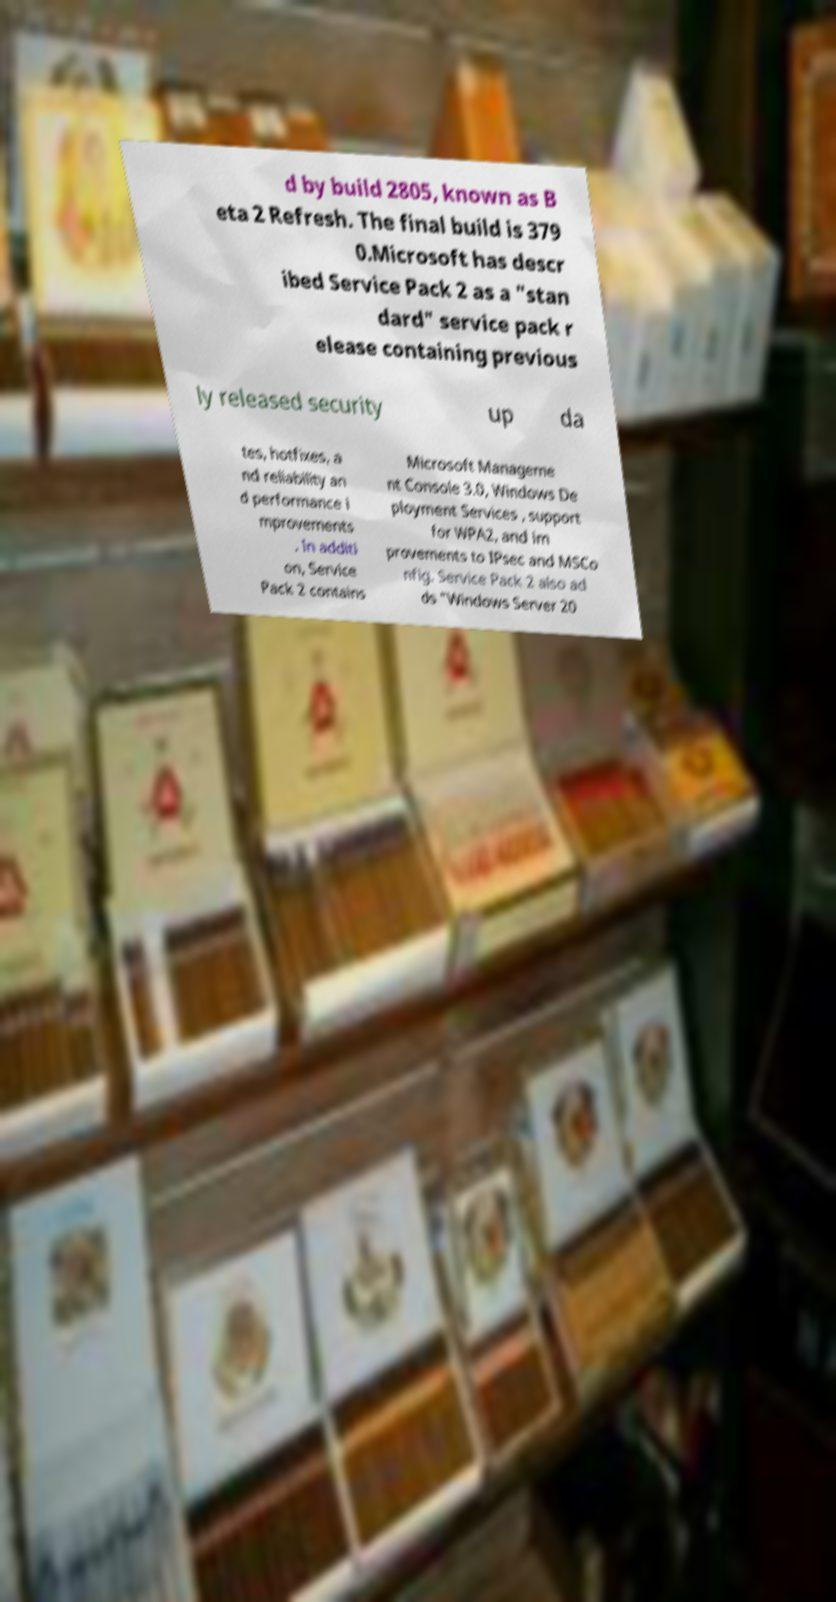Can you accurately transcribe the text from the provided image for me? d by build 2805, known as B eta 2 Refresh. The final build is 379 0.Microsoft has descr ibed Service Pack 2 as a "stan dard" service pack r elease containing previous ly released security up da tes, hotfixes, a nd reliability an d performance i mprovements . In additi on, Service Pack 2 contains Microsoft Manageme nt Console 3.0, Windows De ployment Services , support for WPA2, and im provements to IPsec and MSCo nfig. Service Pack 2 also ad ds "Windows Server 20 